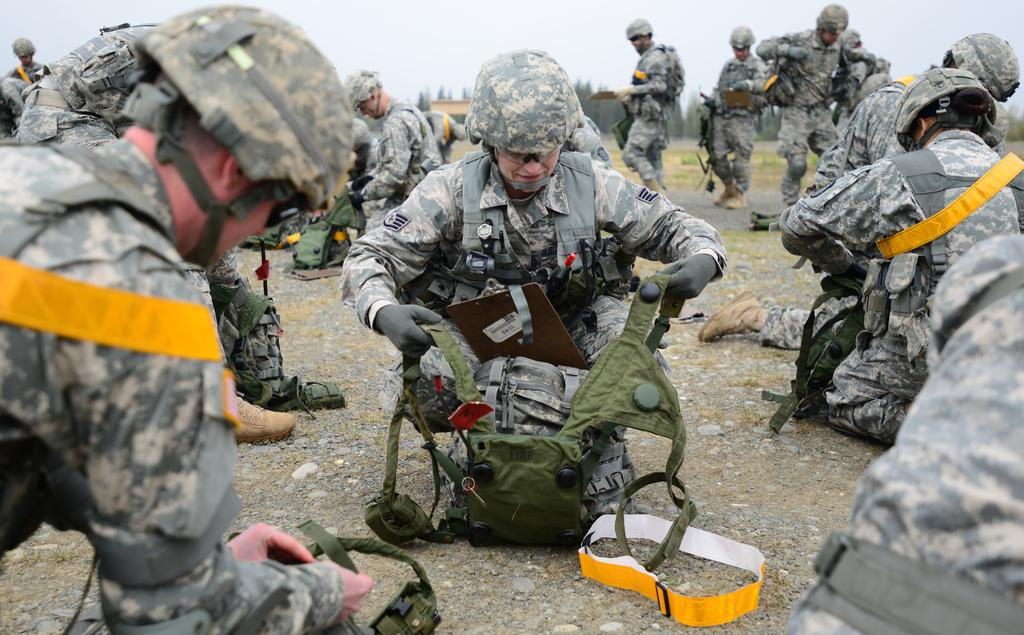How many people are in the image? There are people in the image, but the exact number is not specified. What are some people doing in the image? Some people are holding objects in the image. What type of terrain is visible in the image? There is ground with grass visible in the image. What else can be found on the ground in the image? There are objects on the ground in the image. What type of vegetation is present in the image? There are trees in the image. What part of the natural environment is visible in the image? The sky is visible in the image. What type of insurance policy is being discussed by the people in the image? There is no indication in the image that the people are discussing any type of insurance policy. 